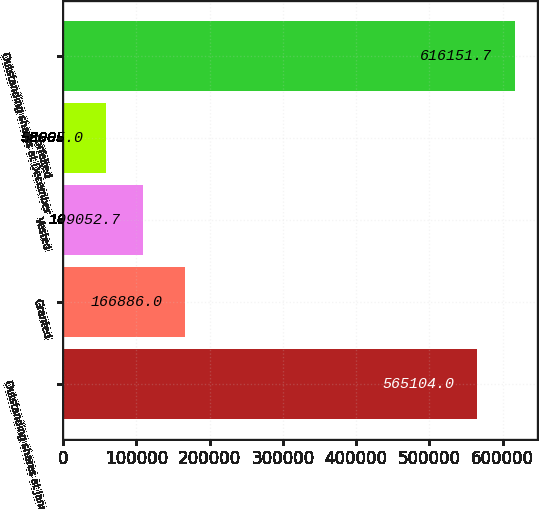<chart> <loc_0><loc_0><loc_500><loc_500><bar_chart><fcel>Outstanding shares at January<fcel>Granted<fcel>Vested<fcel>Forfeited<fcel>Outstanding shares at December<nl><fcel>565104<fcel>166886<fcel>109053<fcel>58005<fcel>616152<nl></chart> 